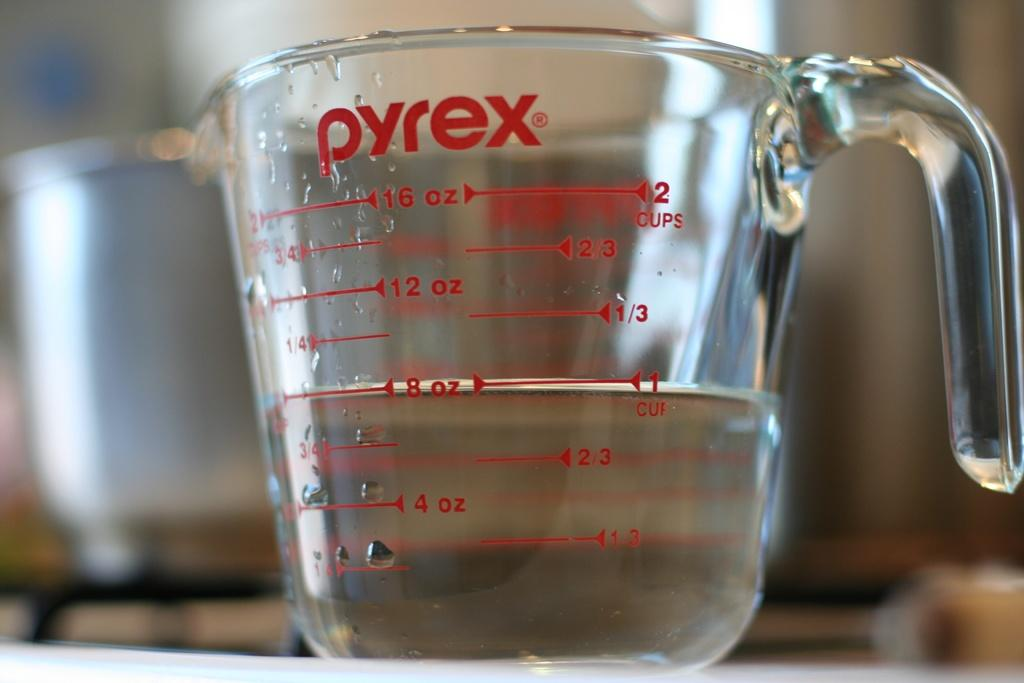<image>
Offer a succinct explanation of the picture presented. Clear liquid in a pyrex measuring cup filled half way. 